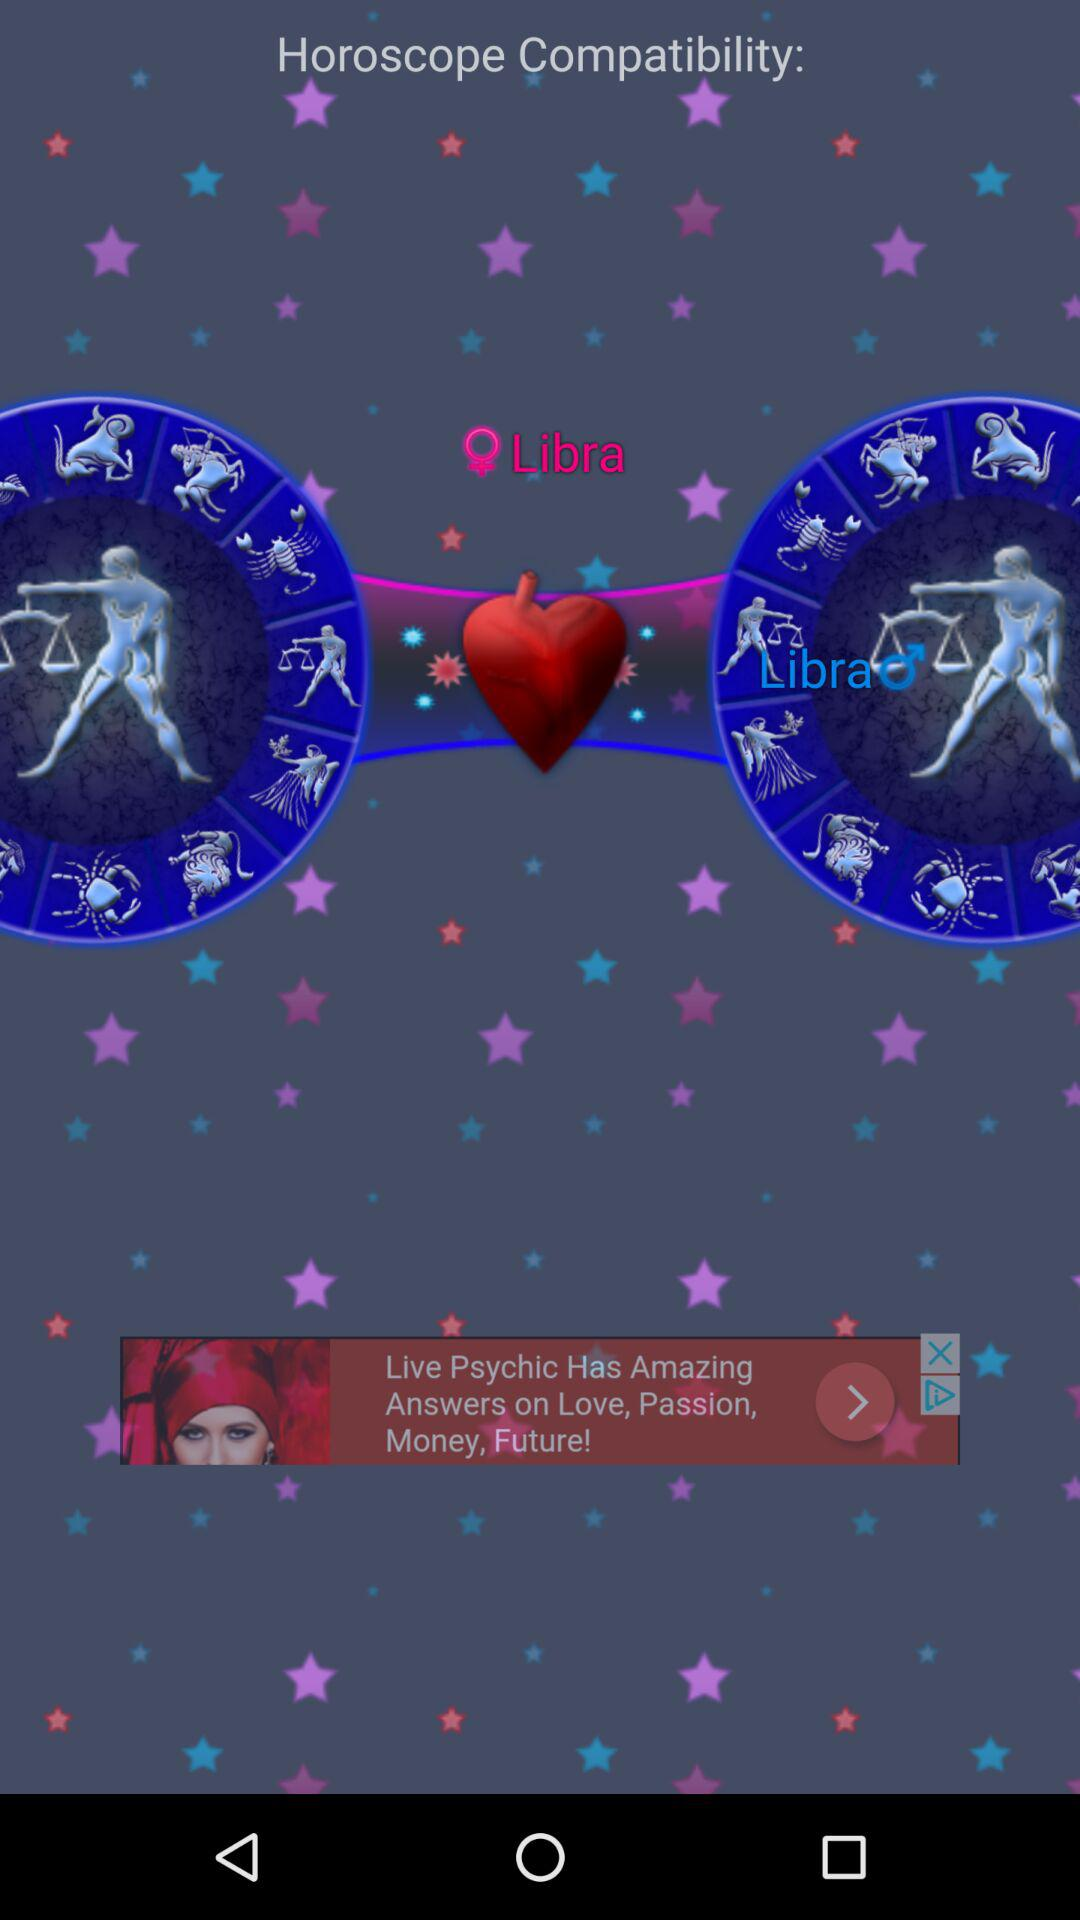How many circles with zodiac signs are there?
Answer the question using a single word or phrase. 2 